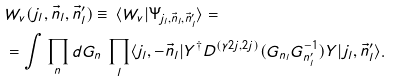Convert formula to latex. <formula><loc_0><loc_0><loc_500><loc_500>& W _ { v } ( j _ { l } , \vec { n } _ { l } , \vec { n } ^ { \prime } _ { l } ) \equiv \, \langle W _ { v } | \Psi _ { j _ { l } , \vec { n } _ { l } , \vec { n } ^ { \prime } _ { l } } \rangle = \\ & = \int \prod _ { n } d G _ { n } \, \prod _ { l } \langle j _ { l } , - \vec { n } _ { l } | Y ^ { \dagger } D ^ { ( \gamma 2 j , 2 j ) } ( G _ { n _ { l } } G ^ { - 1 } _ { n ^ { \prime } _ { l } } ) Y | j _ { l } , \vec { n } ^ { \prime } _ { l } \rangle .</formula> 